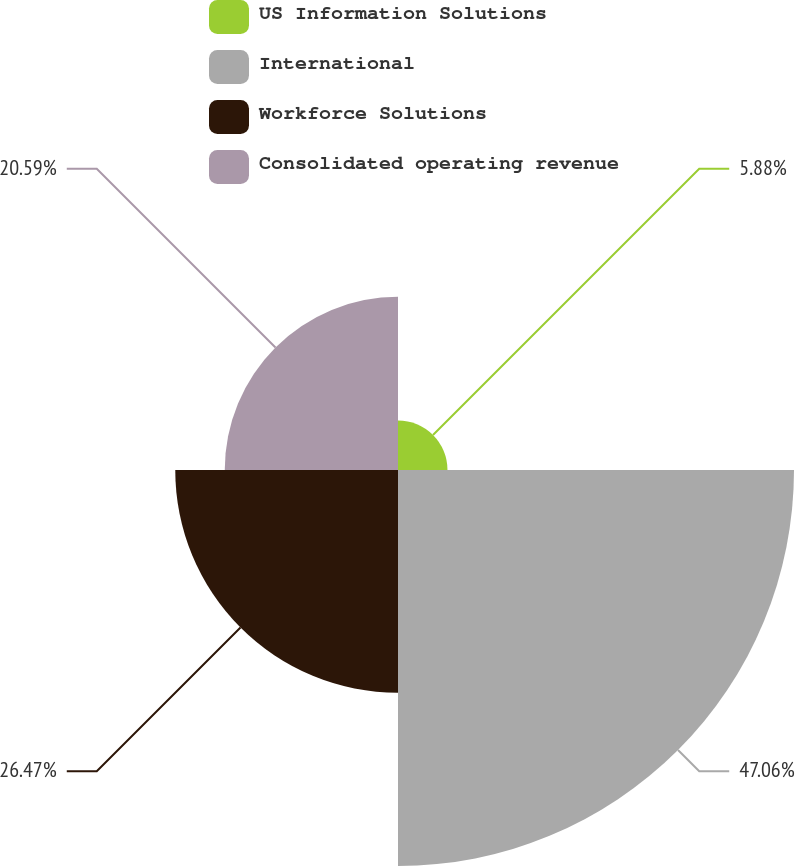Convert chart to OTSL. <chart><loc_0><loc_0><loc_500><loc_500><pie_chart><fcel>US Information Solutions<fcel>International<fcel>Workforce Solutions<fcel>Consolidated operating revenue<nl><fcel>5.88%<fcel>47.06%<fcel>26.47%<fcel>20.59%<nl></chart> 